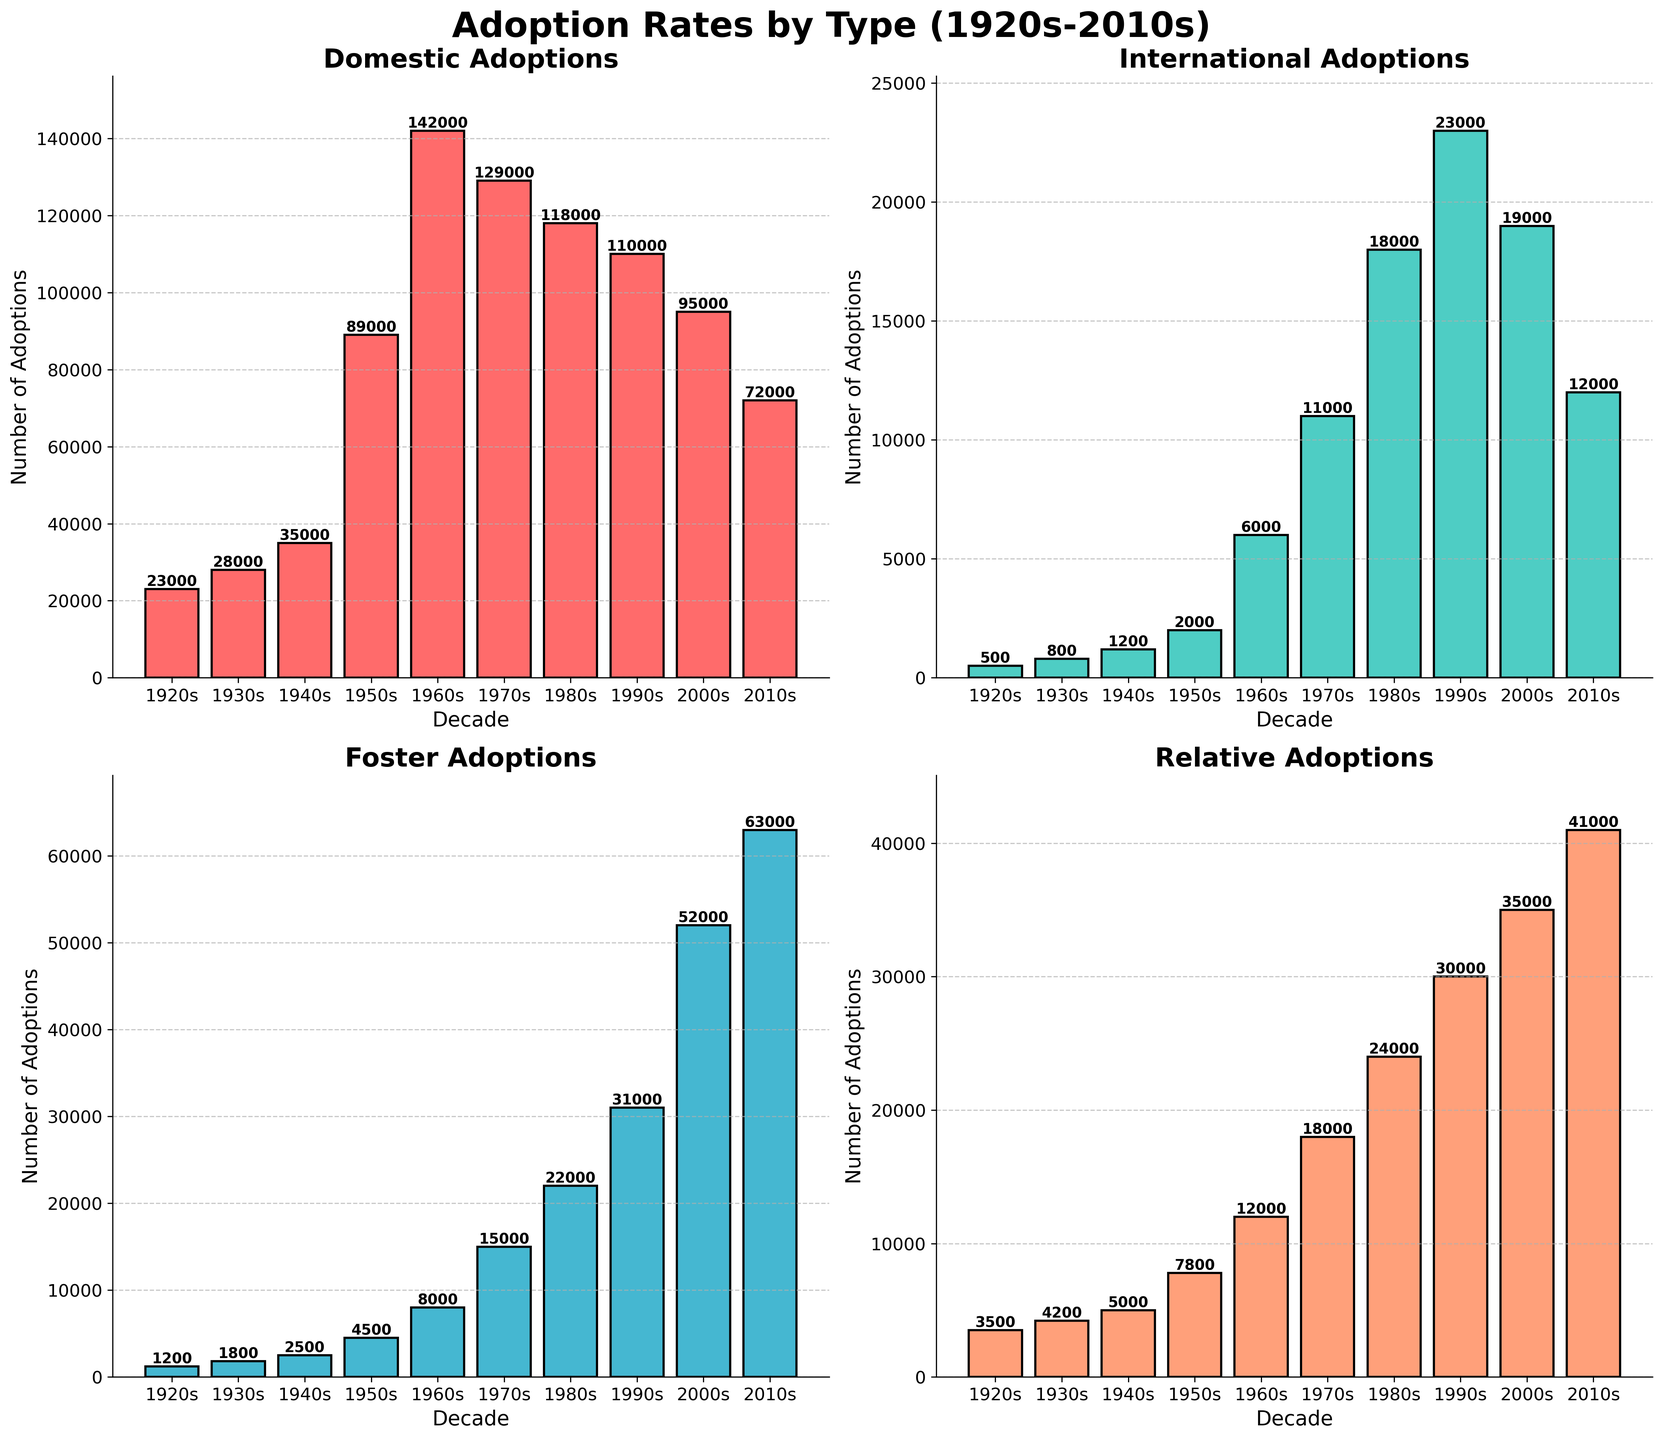What type of adoption had consistently increasing rates until the 1970s and then began to decline? Domestic adoptions increased consistently until the 1970s then began to decline. This can be observed as the height of the bars in the Domestic category for each decade first increases and then decreases starting from the 1980s.
Answer: Domestic Which decade had the highest number of international adoptions? The International adoption subplot shows that the highest bar is in the 1990s, representing 23,000 adoptions, indicating the peak in this decade.
Answer: 1990s When did foster adoptions first exceed 50,000? The Foster adoption subplot shows that the bar height first exceeds 50,000 in the 2000s.
Answer: 2000s How many more relative adoptions occurred in the 2010s compared to the 1920s? In the 2010s, there were 41,000 relative adoptions, and in the 1920s, there were 3,500. Subtracting these two values gives a difference of 37,500.
Answer: 37,500 Which decade saw the greatest increase in domestic adoptions compared to the previous decade? The greatest increase can be seen by the jump from the 1940s (35,000) to the 1950s (89,000), an increase of 54,000.
Answer: 1950s Compare the total number of foster adoptions in the 2000s and 2010s and determine which decade had more. The subplot for foster adoptions shows that the 2010s had 63,000 adoptions, and the 2000s had 52,000. Therefore, the 2010s had more foster adoptions.
Answer: 2010s Which type of adoption has the least variability in the number of adoptions across decades? By visually inspecting the heights of the bars, it's evident that International adoptions have smaller variations in their bar heights compared to other types.
Answer: International In which decade did relative adoptions see the most substantial percentage increase compared to the previous decade? From 1950s to 1960s, relative adoptions increased from 7,800 to 12,000 (a 4,200 or approximately 53.85% increase). This is the most substantial percentage increase compared to other decades.
Answer: 1960s What is the combined total of all types of adoptions in the 1970s? Summing up the adoptions from all four types: Domestic (129,000) + International (11,000) + Foster (15,000) + Relative (18,000), the total is 173,000.
Answer: 173,000 